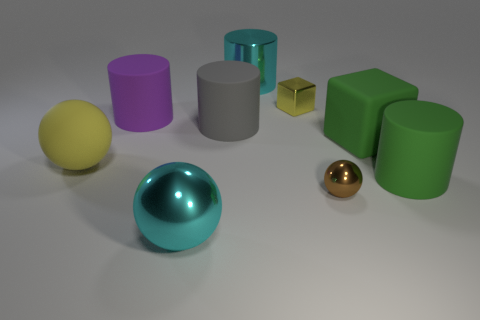What number of big brown cylinders are the same material as the purple thing?
Give a very brief answer. 0. There is a gray matte thing that is the same shape as the purple thing; what size is it?
Offer a terse response. Large. Does the yellow ball have the same size as the green cylinder?
Your response must be concise. Yes. What shape is the big shiny thing that is in front of the yellow object to the right of the purple rubber cylinder in front of the large cyan cylinder?
Your answer should be compact. Sphere. The large rubber thing that is the same shape as the small brown thing is what color?
Offer a very short reply. Yellow. What size is the thing that is both behind the rubber ball and to the right of the tiny ball?
Provide a short and direct response. Large. What number of rubber things are to the right of the cyan shiny object that is right of the object in front of the brown metallic thing?
Your answer should be compact. 2. How many tiny things are either brown things or purple matte cubes?
Provide a short and direct response. 1. Does the sphere that is behind the brown ball have the same material as the brown thing?
Give a very brief answer. No. The large cyan object in front of the big green object on the left side of the big object that is to the right of the large matte cube is made of what material?
Your answer should be very brief. Metal. 